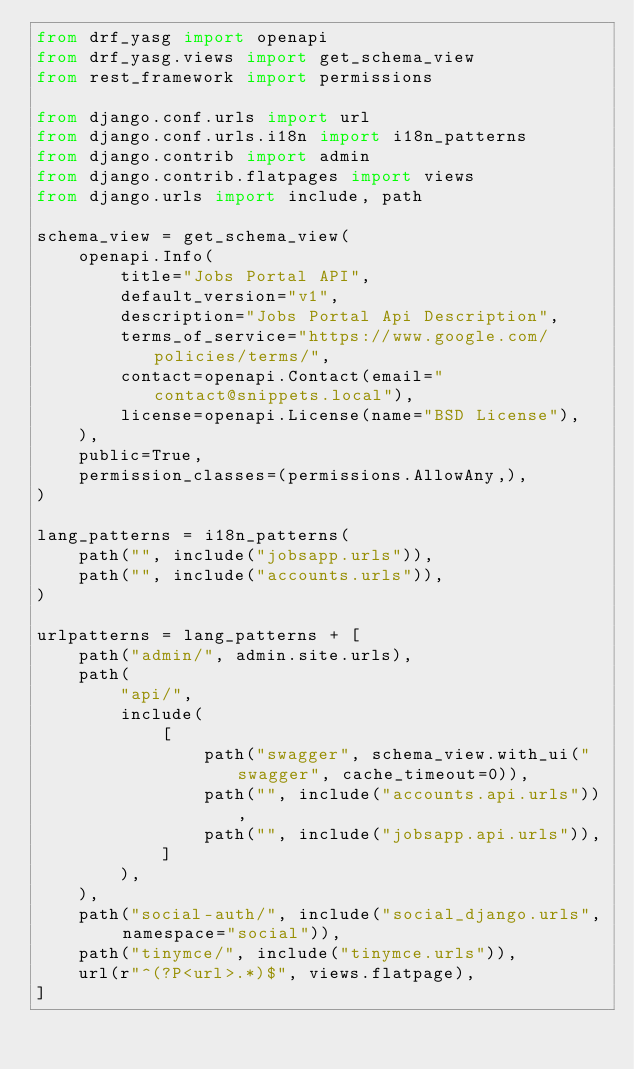<code> <loc_0><loc_0><loc_500><loc_500><_Python_>from drf_yasg import openapi
from drf_yasg.views import get_schema_view
from rest_framework import permissions

from django.conf.urls import url
from django.conf.urls.i18n import i18n_patterns
from django.contrib import admin
from django.contrib.flatpages import views
from django.urls import include, path

schema_view = get_schema_view(
    openapi.Info(
        title="Jobs Portal API",
        default_version="v1",
        description="Jobs Portal Api Description",
        terms_of_service="https://www.google.com/policies/terms/",
        contact=openapi.Contact(email="contact@snippets.local"),
        license=openapi.License(name="BSD License"),
    ),
    public=True,
    permission_classes=(permissions.AllowAny,),
)

lang_patterns = i18n_patterns(
    path("", include("jobsapp.urls")),
    path("", include("accounts.urls")),
)

urlpatterns = lang_patterns + [
    path("admin/", admin.site.urls),
    path(
        "api/",
        include(
            [
                path("swagger", schema_view.with_ui("swagger", cache_timeout=0)),
                path("", include("accounts.api.urls")),
                path("", include("jobsapp.api.urls")),
            ]
        ),
    ),
    path("social-auth/", include("social_django.urls", namespace="social")),
    path("tinymce/", include("tinymce.urls")),
    url(r"^(?P<url>.*)$", views.flatpage),
]
</code> 